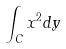<formula> <loc_0><loc_0><loc_500><loc_500>\int _ { C } x ^ { 2 } d y</formula> 